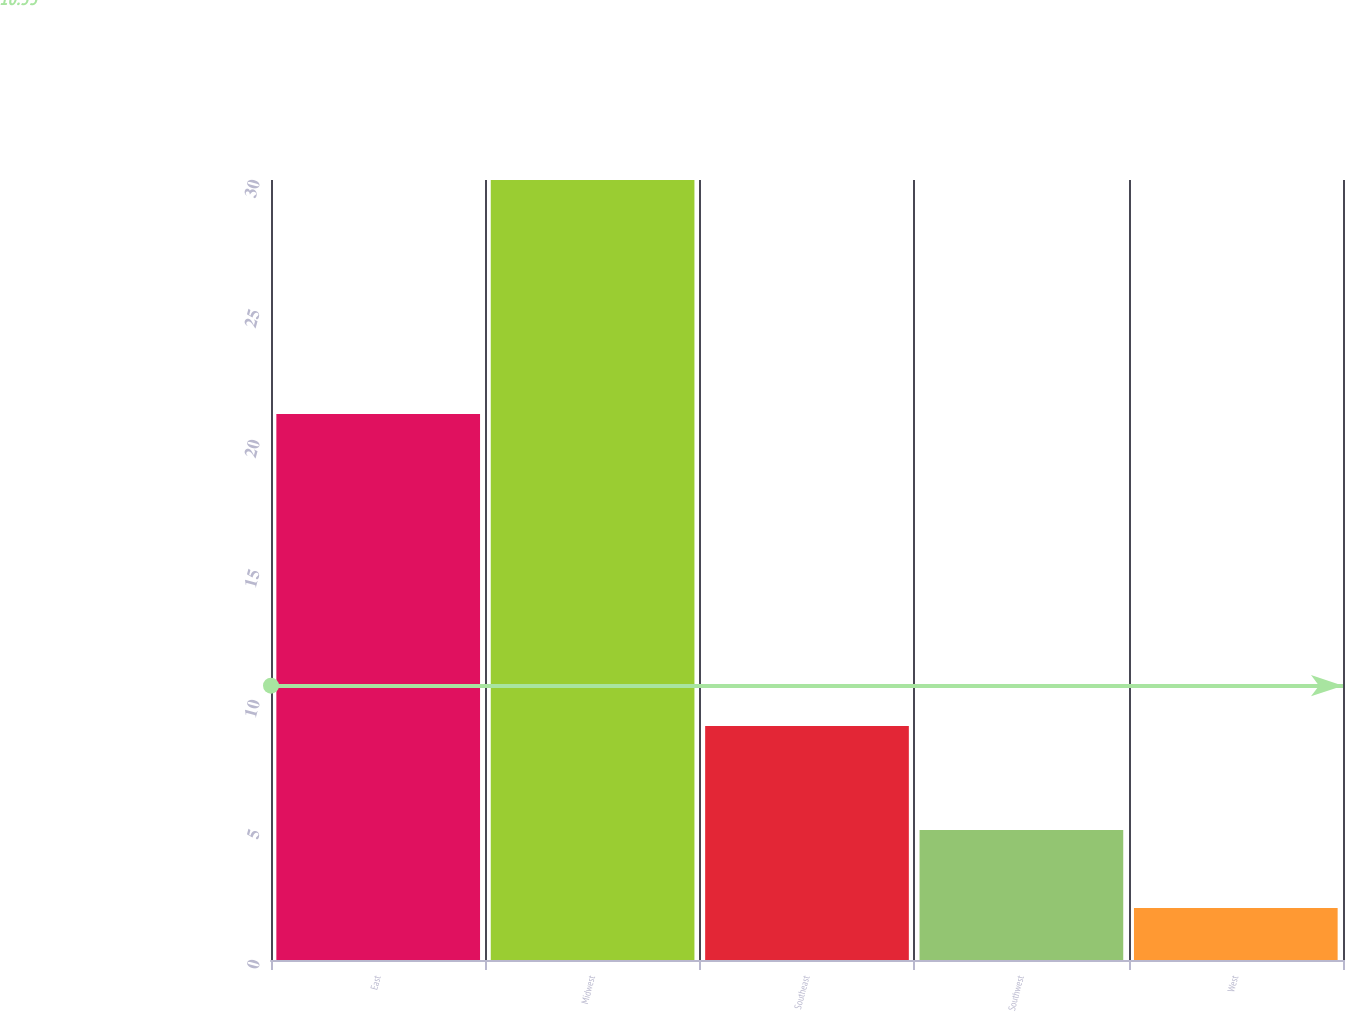Convert chart to OTSL. <chart><loc_0><loc_0><loc_500><loc_500><bar_chart><fcel>East<fcel>Midwest<fcel>Southeast<fcel>Southwest<fcel>West<nl><fcel>21<fcel>30<fcel>9<fcel>5<fcel>2<nl></chart> 